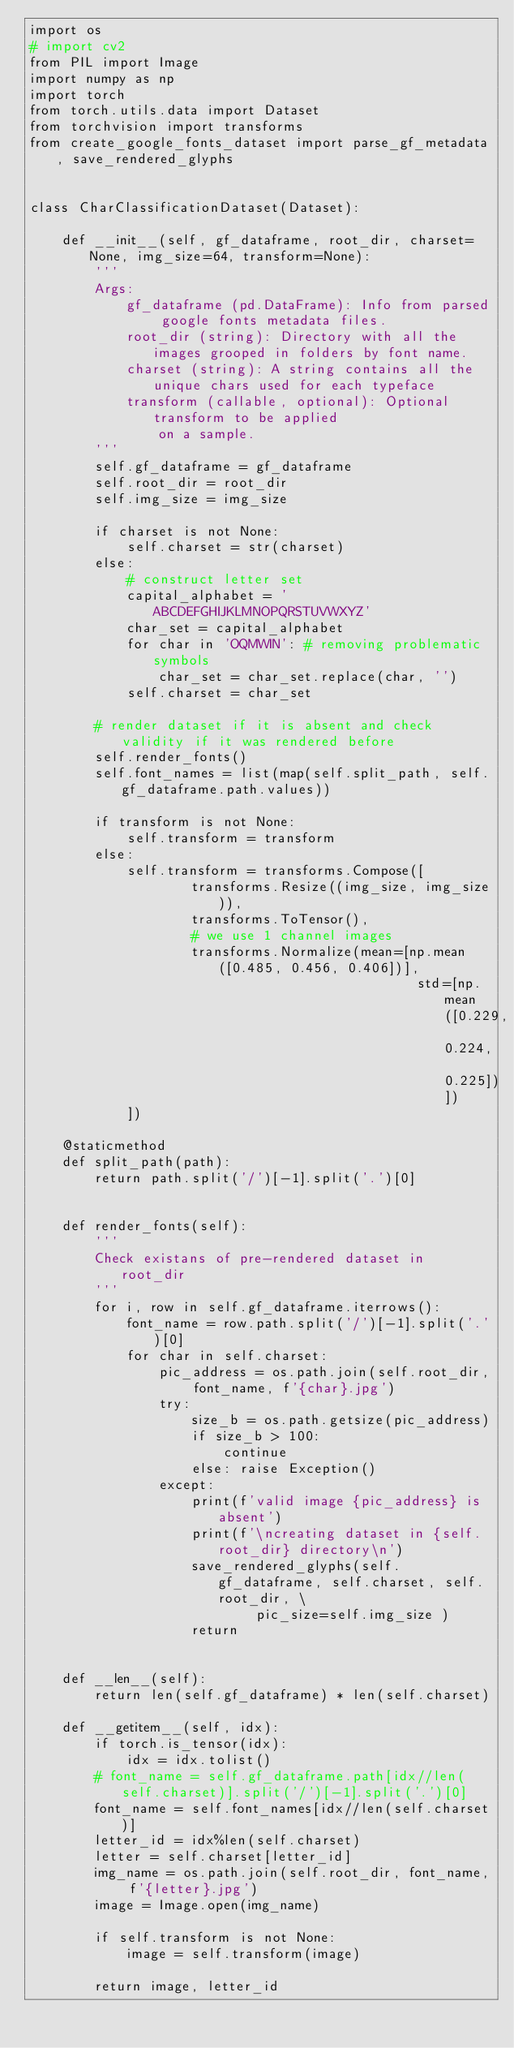Convert code to text. <code><loc_0><loc_0><loc_500><loc_500><_Python_>import os
# import cv2
from PIL import Image
import numpy as np
import torch
from torch.utils.data import Dataset
from torchvision import transforms
from create_google_fonts_dataset import parse_gf_metadata, save_rendered_glyphs


class CharClassificationDataset(Dataset):

    def __init__(self, gf_dataframe, root_dir, charset=None, img_size=64, transform=None):
        '''
        Args:
            gf_dataframe (pd.DataFrame): Info from parsed google fonts metadata files.
            root_dir (string): Directory with all the images grooped in folders by font name.
            charset (string): A string contains all the unique chars used for each typeface
            transform (callable, optional): Optional transform to be applied
                on a sample.
        '''
        self.gf_dataframe = gf_dataframe
        self.root_dir = root_dir
        self.img_size = img_size

        if charset is not None:
            self.charset = str(charset)
        else:
            # construct letter set
            capital_alphabet = 'ABCDEFGHIJKLMNOPQRSTUVWXYZ'
            char_set = capital_alphabet
            for char in 'OQMWIN': # removing problematic symbols
                char_set = char_set.replace(char, '')
            self.charset = char_set
        
        # render dataset if it is absent and check validity if it was rendered before
        self.render_fonts()
        self.font_names = list(map(self.split_path, self.gf_dataframe.path.values))

        if transform is not None:
            self.transform = transform
        else:
            self.transform = transforms.Compose([
                    transforms.Resize((img_size, img_size)),
                    transforms.ToTensor(),
                    # we use 1 channel images
                    transforms.Normalize(mean=[np.mean([0.485, 0.456, 0.406])],
                                                std=[np.mean([0.229, 0.224, 0.225])]) 
            ])        

    @staticmethod
    def split_path(path):
        return path.split('/')[-1].split('.')[0]
        
        
    def render_fonts(self):
        '''
        Check existans of pre-rendered dataset in root_dir
        '''
        for i, row in self.gf_dataframe.iterrows():
            font_name = row.path.split('/')[-1].split('.')[0]
            for char in self.charset:
                pic_address = os.path.join(self.root_dir, font_name, f'{char}.jpg')
                try:
                    size_b = os.path.getsize(pic_address)
                    if size_b > 100:
                        continue
                    else: raise Exception()
                except:
                    print(f'valid image {pic_address} is absent')
                    print(f'\ncreating dataset in {self.root_dir} directory\n')
                    save_rendered_glyphs(self.gf_dataframe, self.charset, self.root_dir, \
                            pic_size=self.img_size )
                    return
                

    def __len__(self):
        return len(self.gf_dataframe) * len(self.charset)

    def __getitem__(self, idx):
        if torch.is_tensor(idx):
            idx = idx.tolist()
        # font_name = self.gf_dataframe.path[idx//len(self.charset)].split('/')[-1].split('.')[0]
        font_name = self.font_names[idx//len(self.charset)]
        letter_id = idx%len(self.charset)
        letter = self.charset[letter_id]
        img_name = os.path.join(self.root_dir, font_name, f'{letter}.jpg')
        image = Image.open(img_name)

        if self.transform is not None:
            image = self.transform(image)

        return image, letter_id</code> 